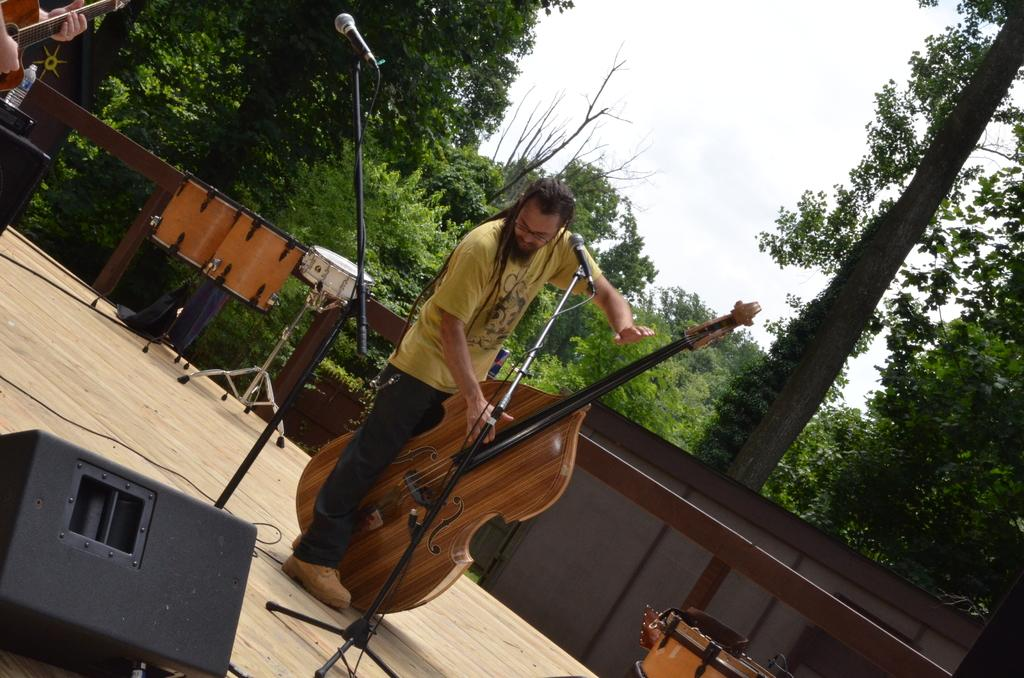How many people are on the stage in the image? There are two people standing on the stage in the image. What is one of the people holding? One person is holding a guitar. What equipment is present for amplifying sound in the image? There is a mic and stand in front of the people. What can be seen in the background of the image? Trees and the sky are visible in the background of the image. What type of marble is visible on the stage in the image? There is no marble visible on the stage in the image. How many horses are present in the image? There are no horses present in the image. 